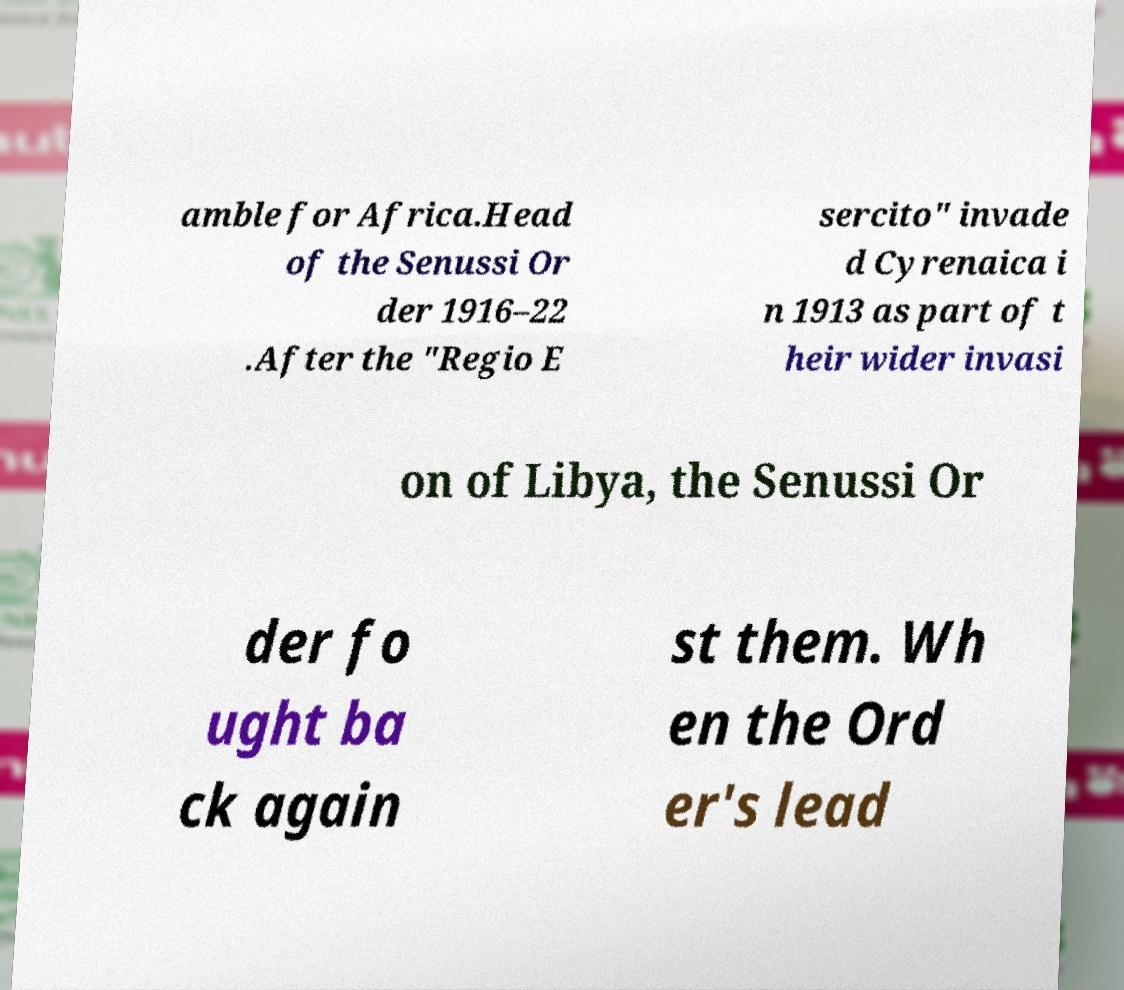Could you assist in decoding the text presented in this image and type it out clearly? amble for Africa.Head of the Senussi Or der 1916–22 .After the "Regio E sercito" invade d Cyrenaica i n 1913 as part of t heir wider invasi on of Libya, the Senussi Or der fo ught ba ck again st them. Wh en the Ord er's lead 